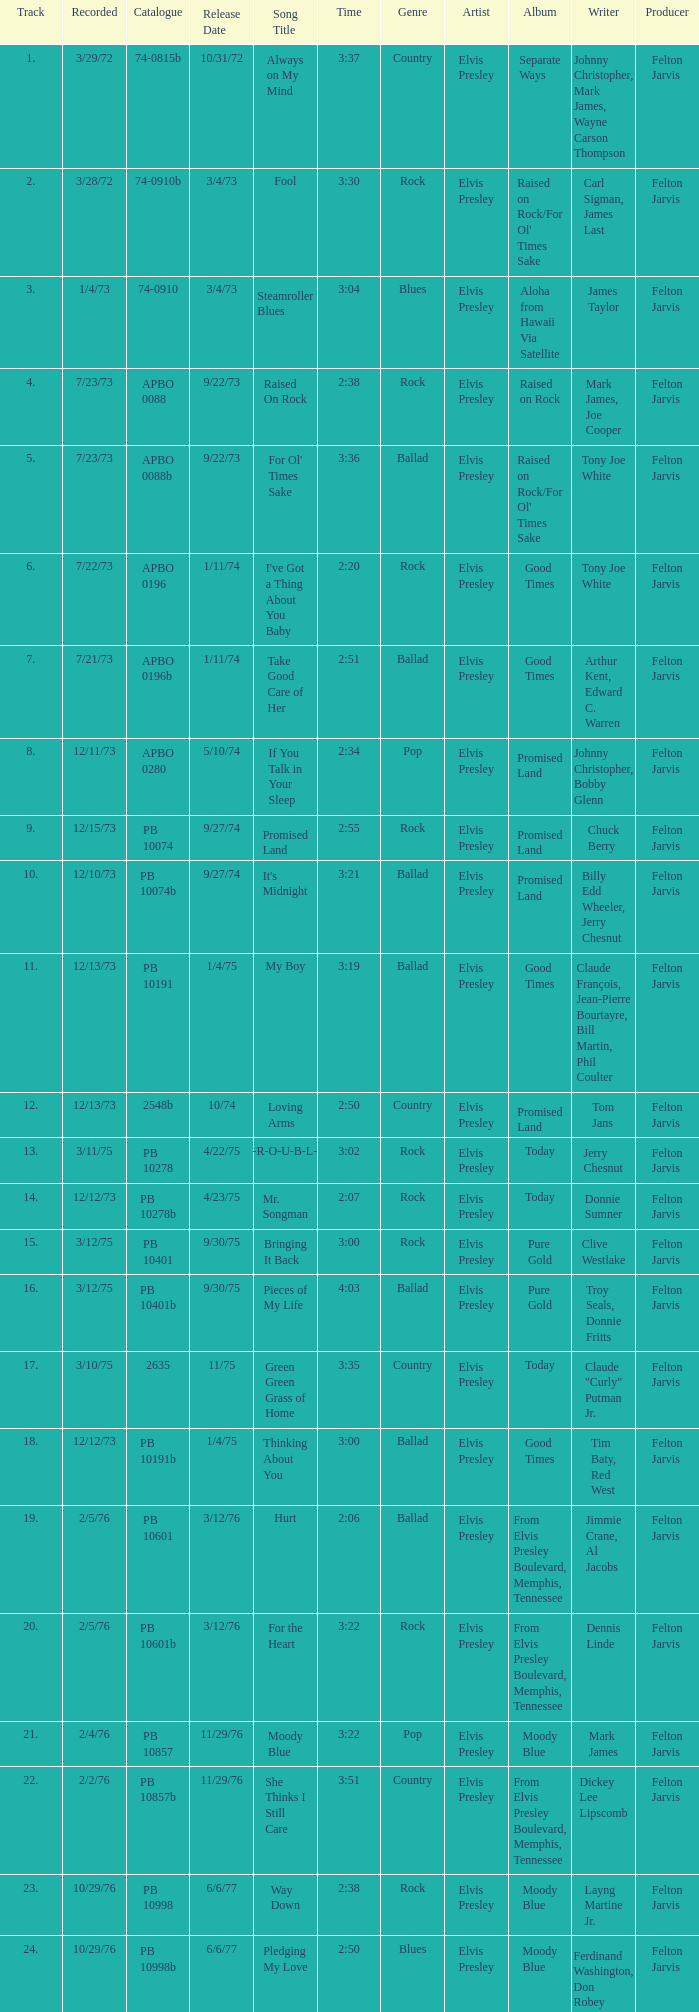Name the catalogue that has tracks less than 13 and the release date of 10/31/72 74-0815b. 